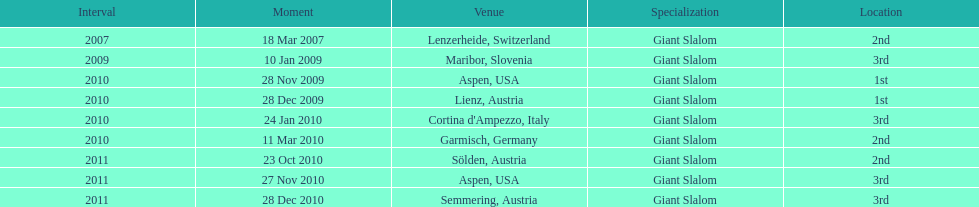What is the only location in the us? Aspen. 